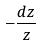<formula> <loc_0><loc_0><loc_500><loc_500>- \frac { d z } { z }</formula> 